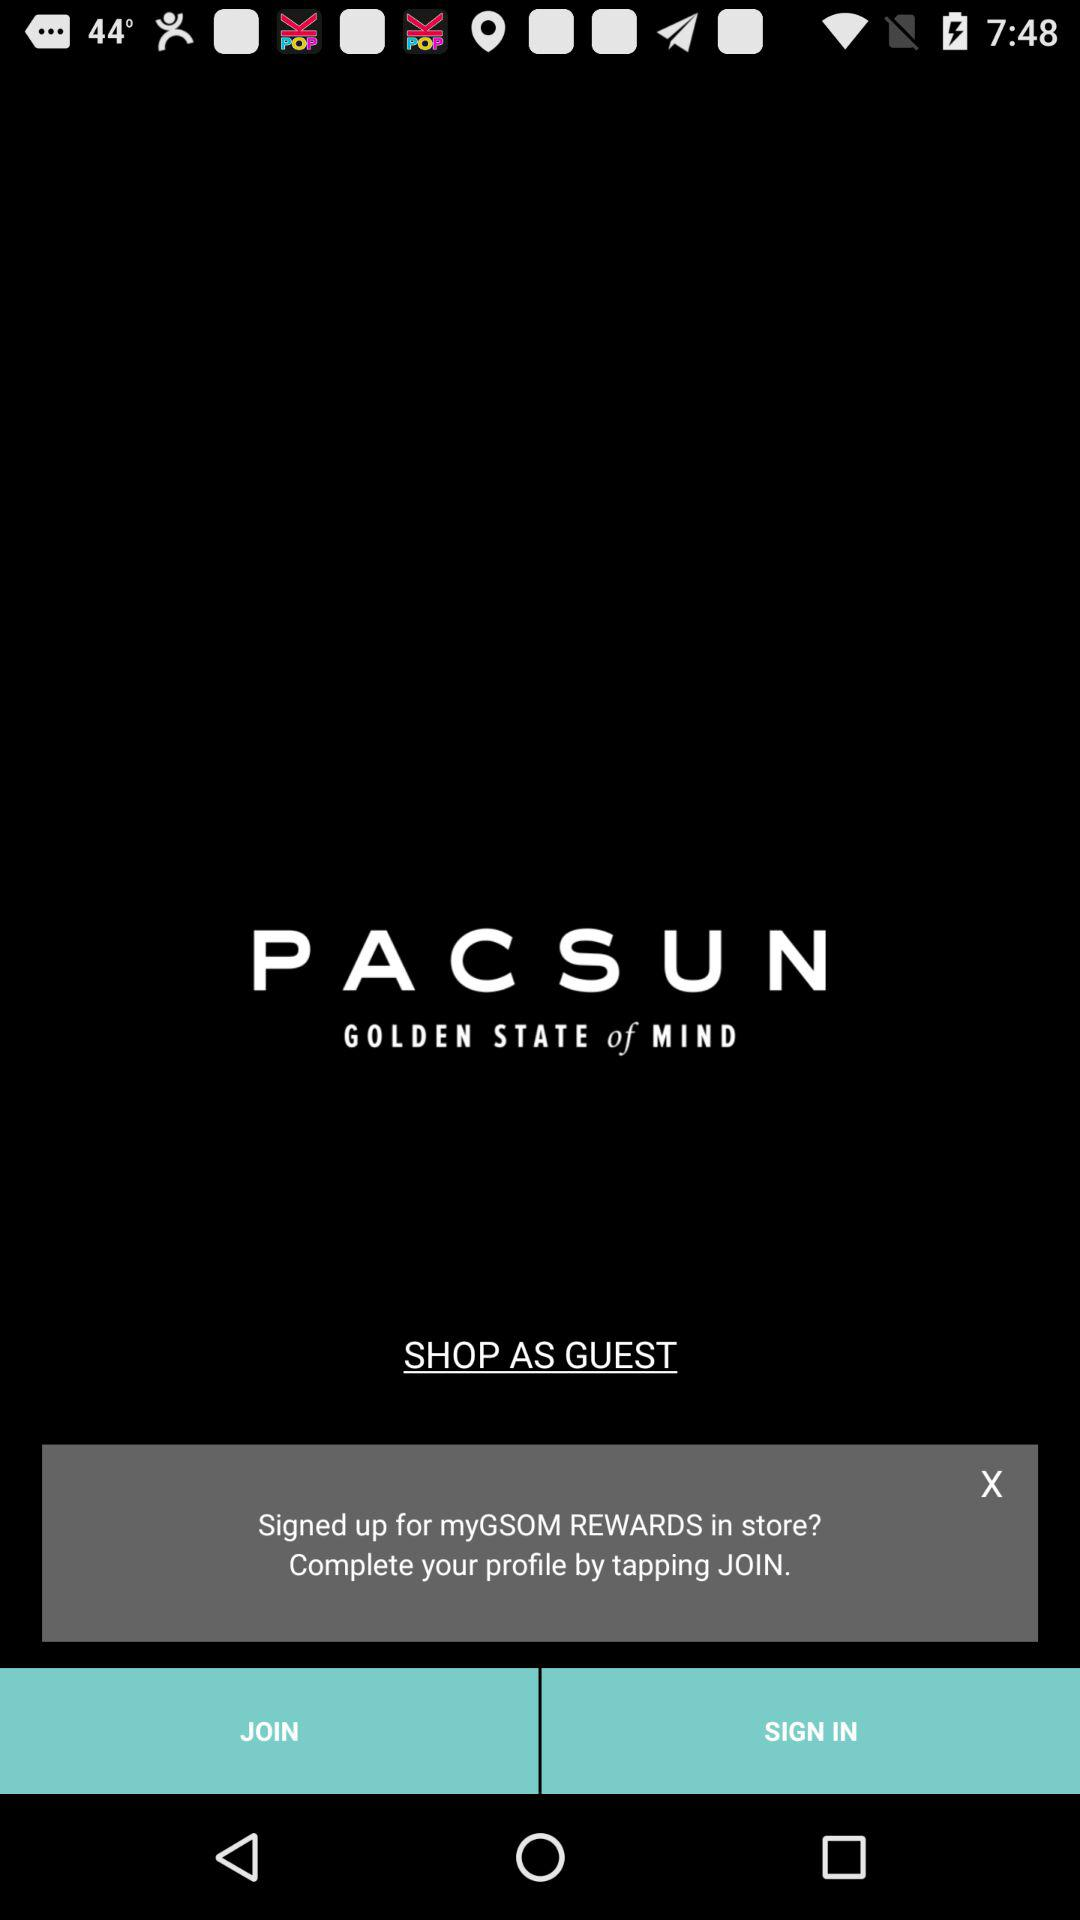What is the application name? The application name is "P A C S U N". 